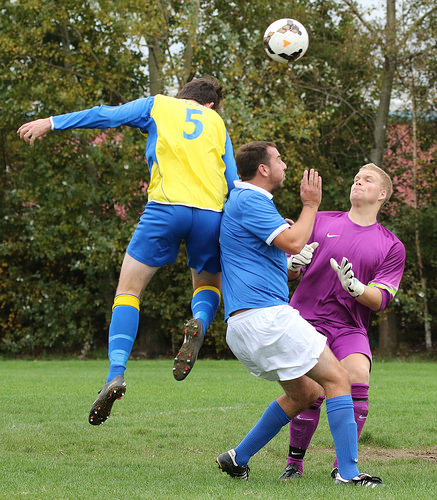<image>
Is there a man in front of the man? No. The man is not in front of the man. The spatial positioning shows a different relationship between these objects. Is the football above the man? Yes. The football is positioned above the man in the vertical space, higher up in the scene. 